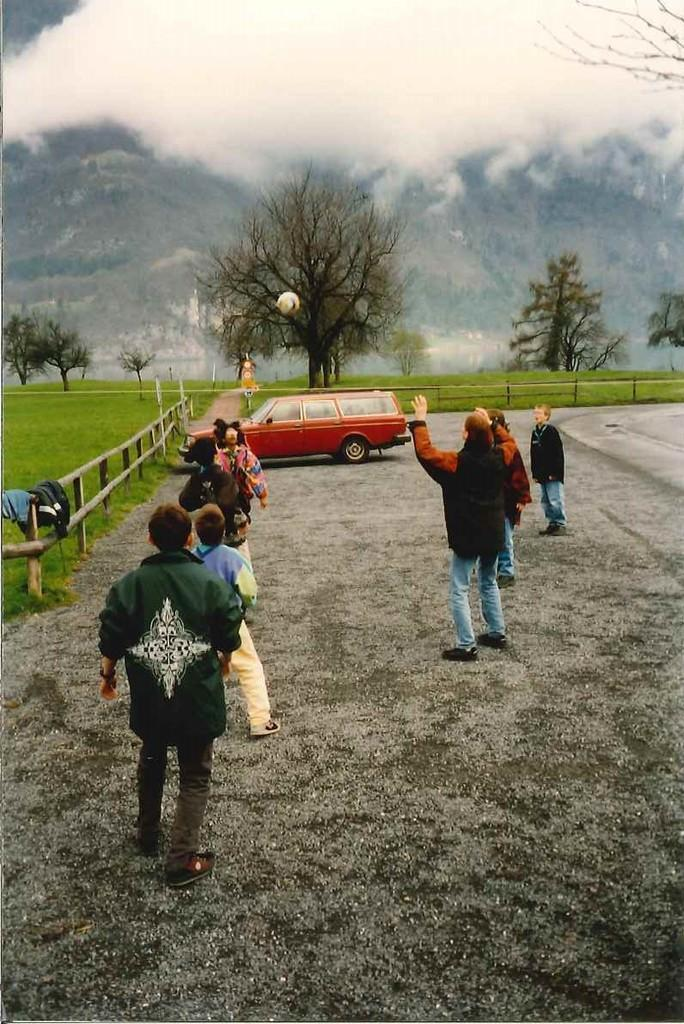What can be seen on the path in the image? There are people on the path in the image. What type of fencing is visible in the background? There are wooden fences in the background of the image. What else can be seen in the background of the image? Clothes, poles, trees, grass, a vehicle, a hill, and fog are present in the background of the image. What is in the air in the image? There is a ball in the air in the image. What type of key is used to unlock the manager's office in the image? There is no manager or office present in the image, and therefore no key can be associated with it. What type of eggnog is being served at the event in the image? There is no event or eggnog present in the image. 